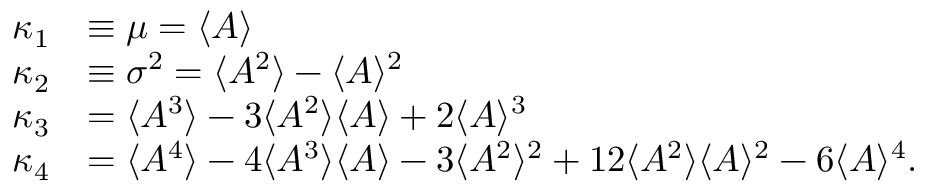<formula> <loc_0><loc_0><loc_500><loc_500>\begin{array} { r l } { \kappa _ { 1 } } & { \equiv \mu = \langle { A } \rangle } \\ { \kappa _ { 2 } } & { \equiv \sigma ^ { 2 } = \langle { A ^ { 2 } } \rangle - \langle { A } \rangle ^ { 2 } } \\ { \kappa _ { 3 } } & { = \langle { A ^ { 3 } } \rangle - 3 \langle { A ^ { 2 } } \rangle \langle { A } \rangle + 2 \langle { A } \rangle ^ { 3 } } \\ { \kappa _ { 4 } } & { = \langle { A ^ { 4 } } \rangle - 4 \langle { A ^ { 3 } } \rangle \langle { A } \rangle - 3 \langle { A ^ { 2 } } \rangle ^ { 2 } + 1 2 \langle { A ^ { 2 } } \rangle \langle { A } \rangle ^ { 2 } - 6 \langle { A } \rangle ^ { 4 } . } \end{array}</formula> 